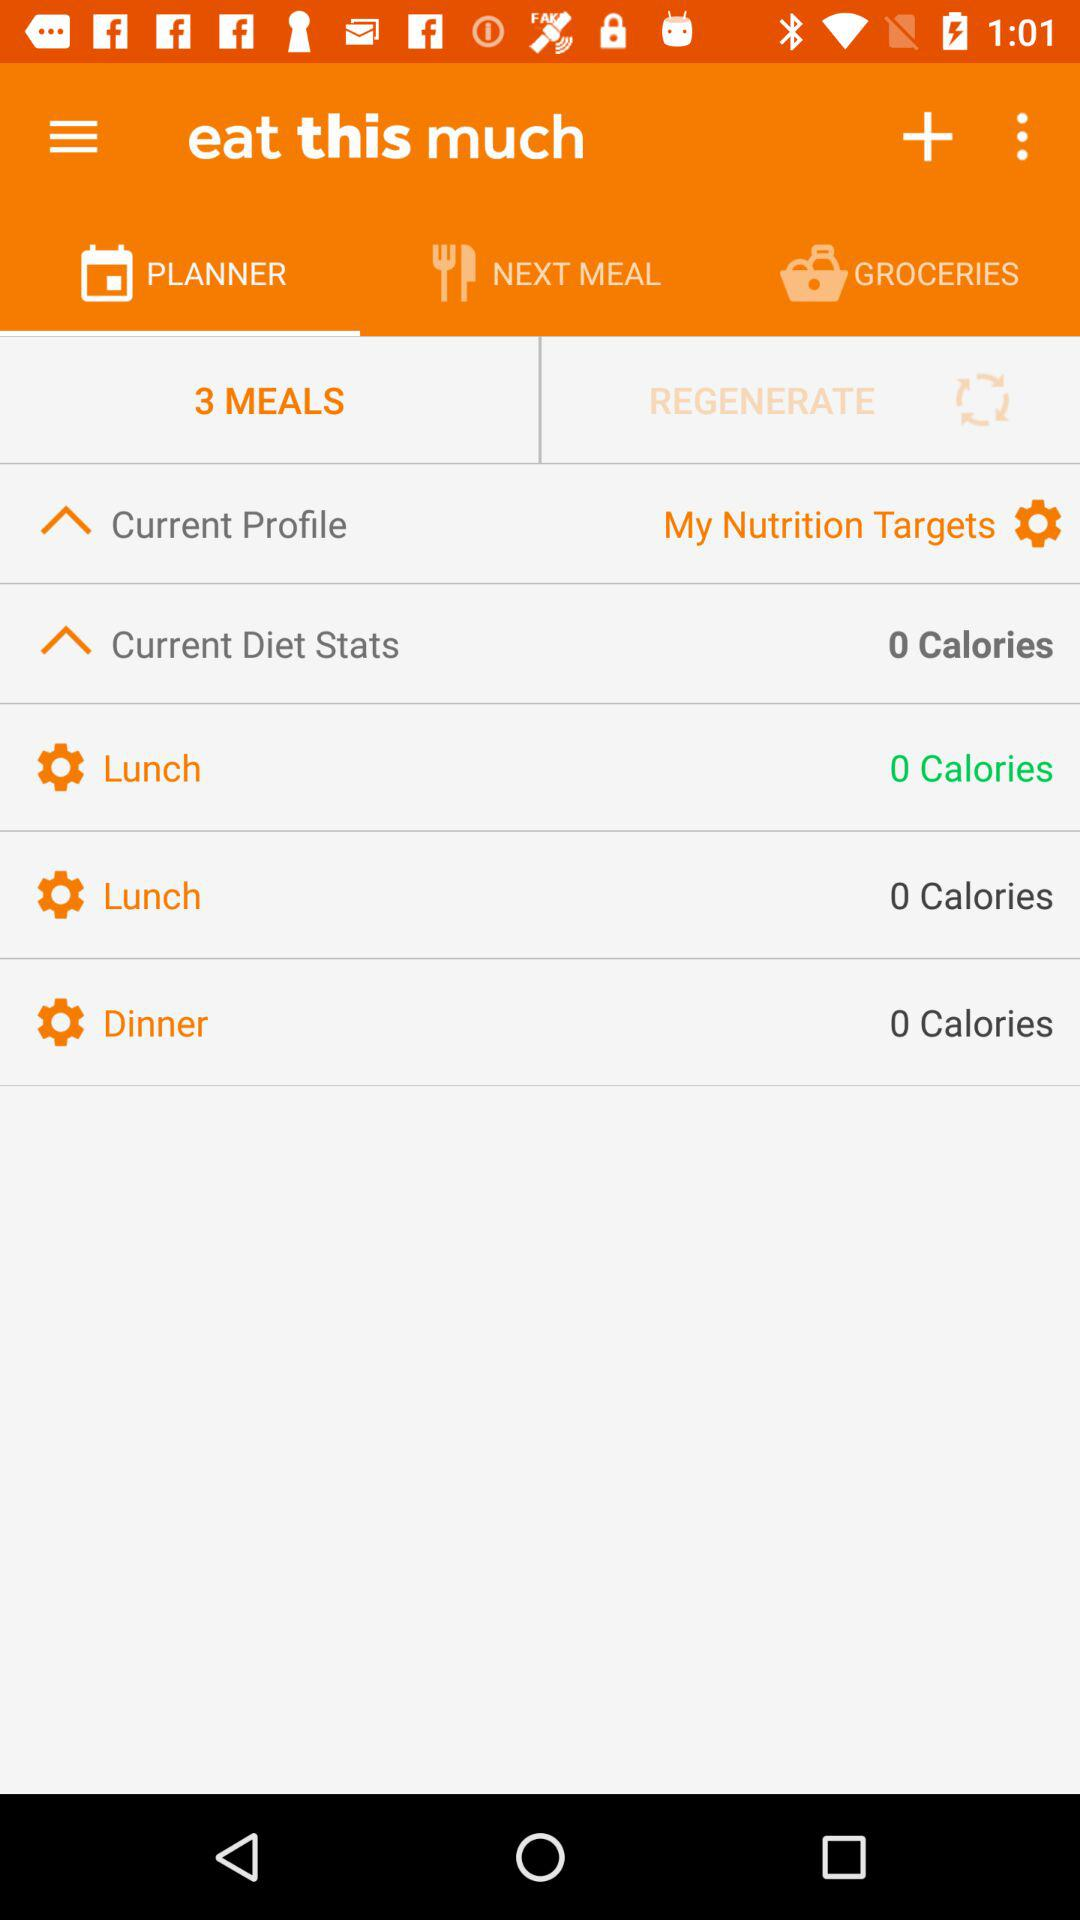How many calories are shown in the current diet stats?
Answer the question using a single word or phrase. 0 